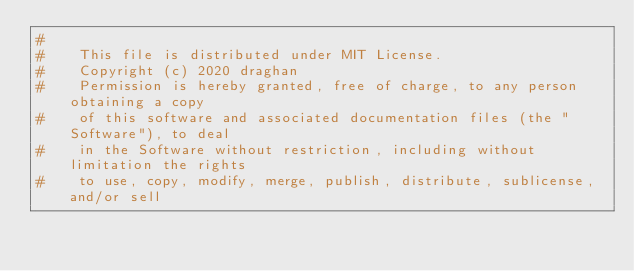Convert code to text. <code><loc_0><loc_0><loc_500><loc_500><_Python_>#
#    This file is distributed under MIT License.
#    Copyright (c) 2020 draghan
#    Permission is hereby granted, free of charge, to any person obtaining a copy
#    of this software and associated documentation files (the "Software"), to deal
#    in the Software without restriction, including without limitation the rights
#    to use, copy, modify, merge, publish, distribute, sublicense, and/or sell</code> 